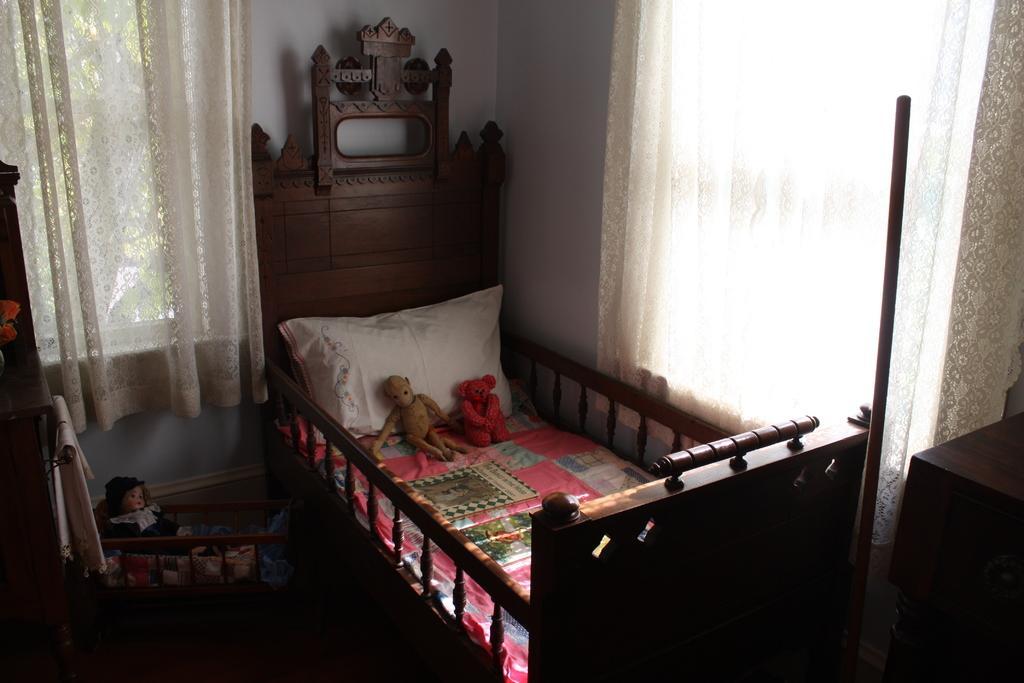Could you give a brief overview of what you see in this image? In this picture we can see bed and on bed we have pillow, two toys and aside to this bed we have one more toy and in the background we can see curtain, wall. 